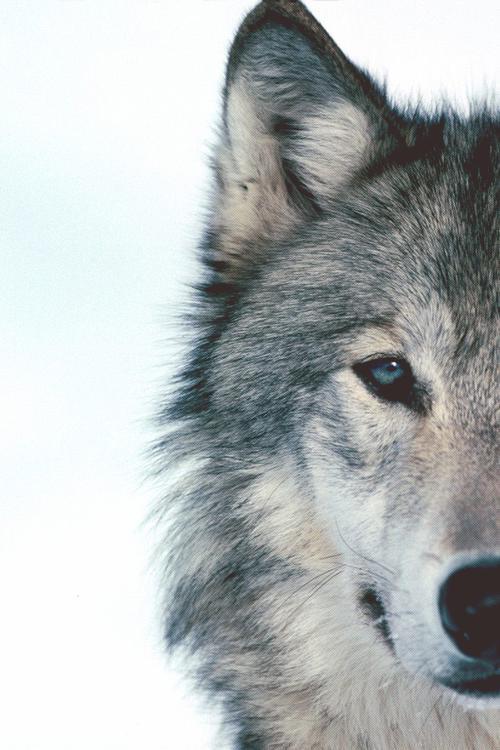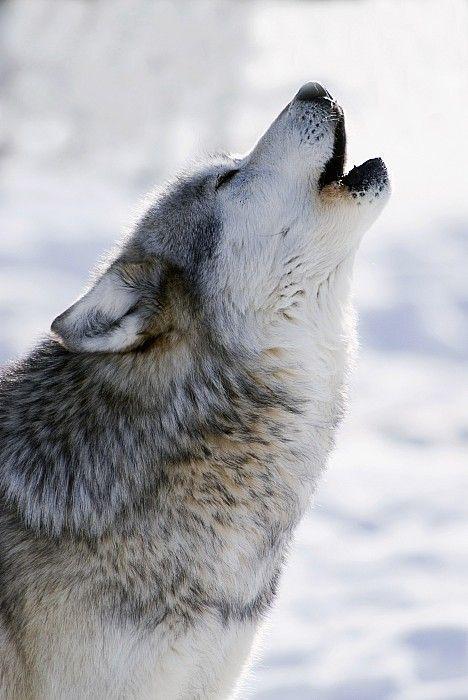The first image is the image on the left, the second image is the image on the right. Given the left and right images, does the statement "Four howling wolves are shown against dark and stormy skies." hold true? Answer yes or no. No. The first image is the image on the left, the second image is the image on the right. For the images shown, is this caption "Each image shows exactly one howling wolf." true? Answer yes or no. No. 